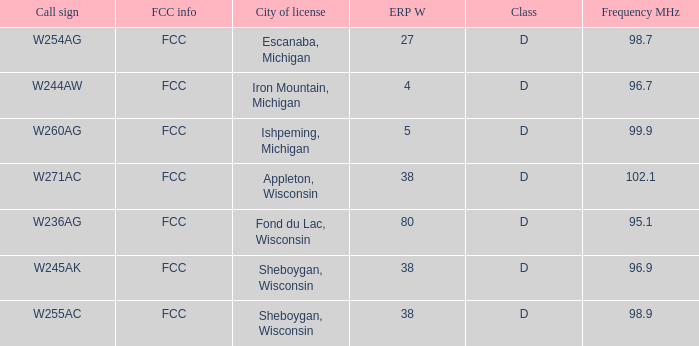What was the class for Appleton, Wisconsin? D. 